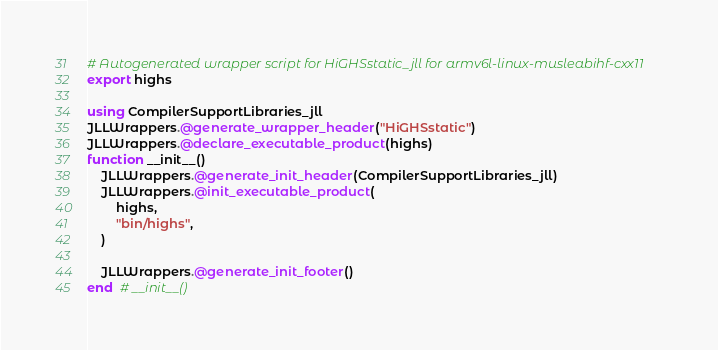<code> <loc_0><loc_0><loc_500><loc_500><_Julia_># Autogenerated wrapper script for HiGHSstatic_jll for armv6l-linux-musleabihf-cxx11
export highs

using CompilerSupportLibraries_jll
JLLWrappers.@generate_wrapper_header("HiGHSstatic")
JLLWrappers.@declare_executable_product(highs)
function __init__()
    JLLWrappers.@generate_init_header(CompilerSupportLibraries_jll)
    JLLWrappers.@init_executable_product(
        highs,
        "bin/highs",
    )

    JLLWrappers.@generate_init_footer()
end  # __init__()
</code> 